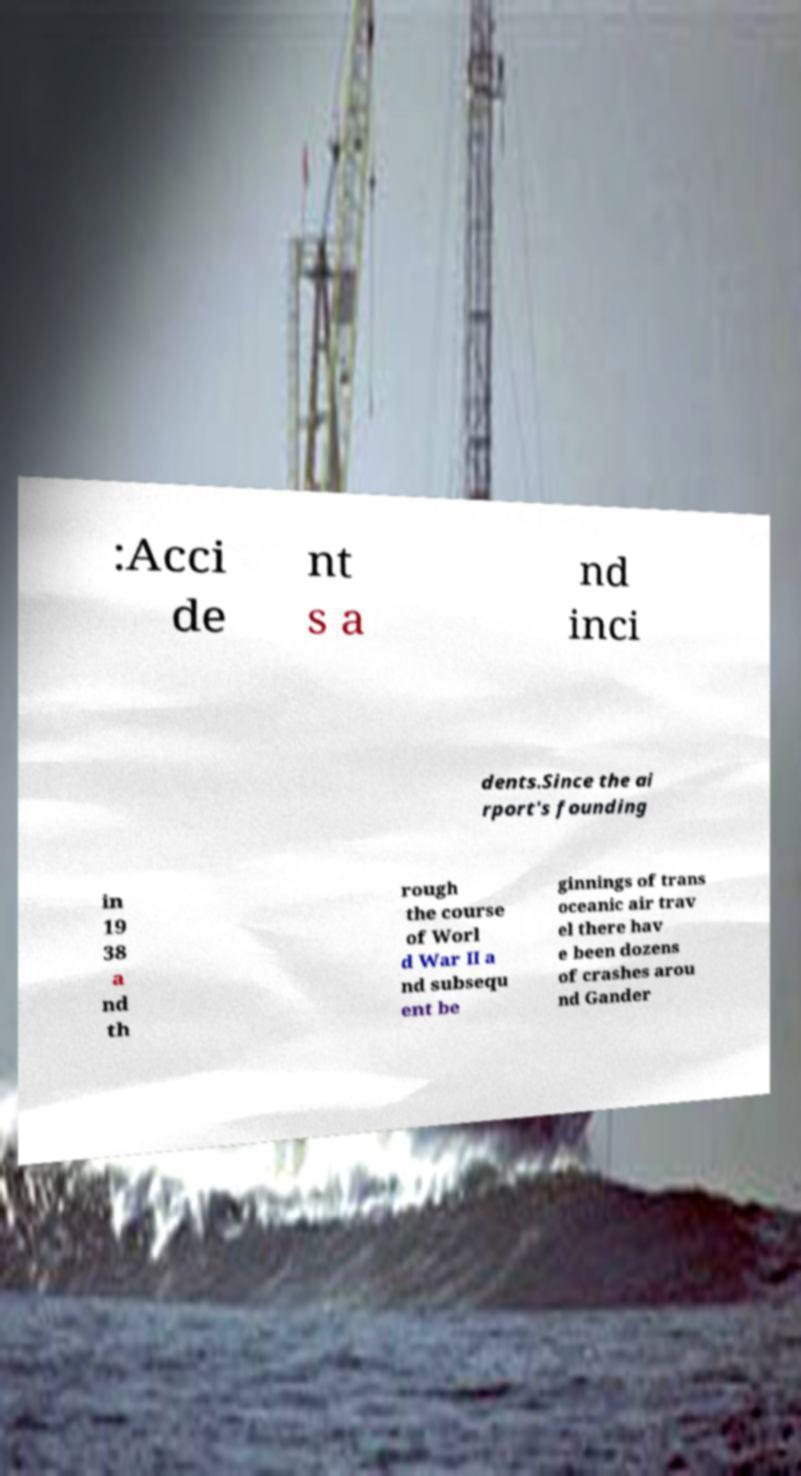For documentation purposes, I need the text within this image transcribed. Could you provide that? :Acci de nt s a nd inci dents.Since the ai rport's founding in 19 38 a nd th rough the course of Worl d War II a nd subsequ ent be ginnings of trans oceanic air trav el there hav e been dozens of crashes arou nd Gander 